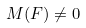Convert formula to latex. <formula><loc_0><loc_0><loc_500><loc_500>M ( F ) \ne 0</formula> 